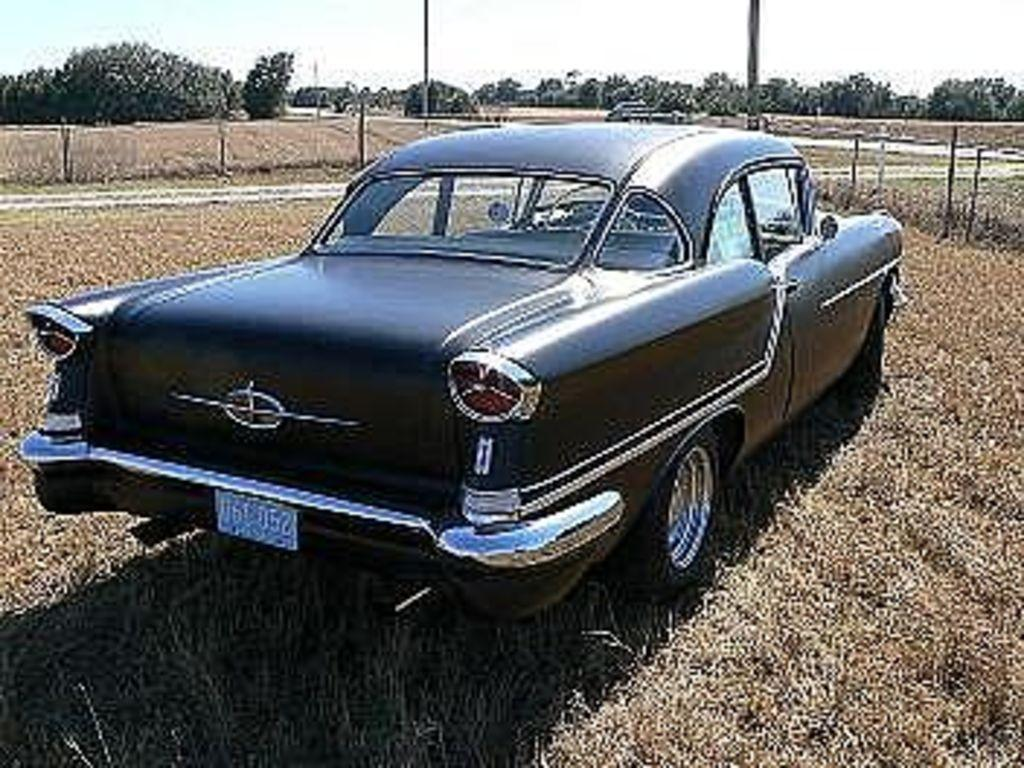What is located on the ground in the image? There is a vehicle on the ground in the image. What type of natural vegetation can be seen in the image? There are trees and grass in the image. What structures are present in the image? There are poles in the image. What part of the natural environment is visible in the image? The sky is visible in the image. What type of beef is being served to the passengers in the image? There is no beef or passengers present in the image; it features a vehicle, trees, poles, grass, and the sky. 